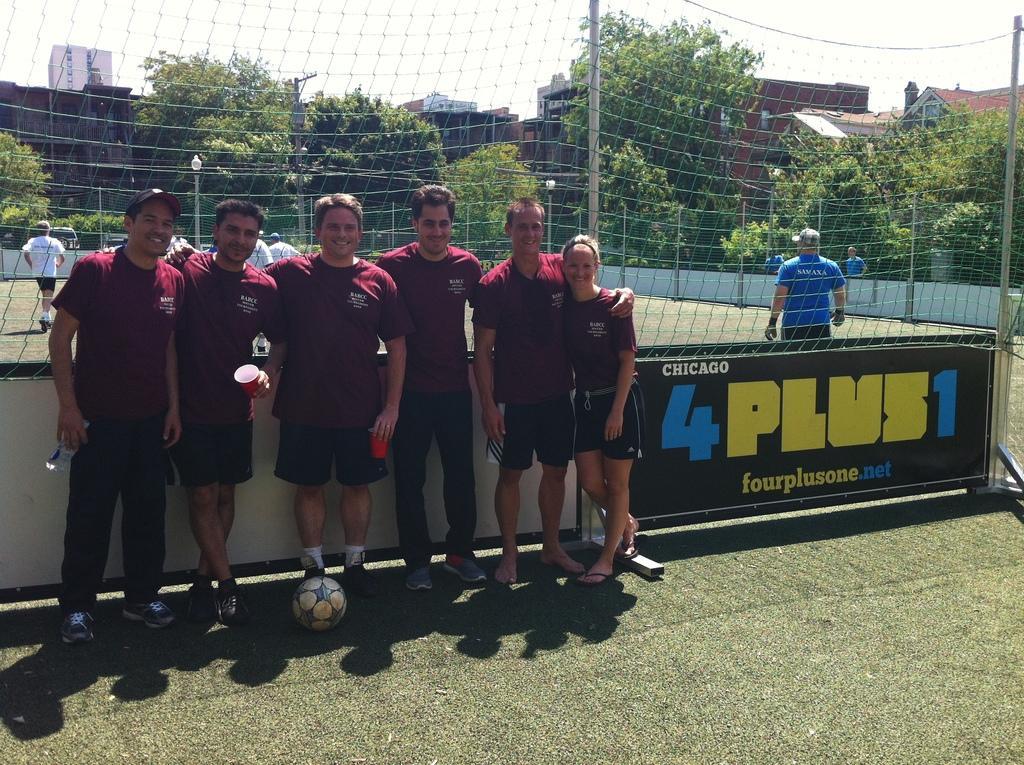Please provide a concise description of this image. In this image we can see the players standing on the ground. We can also see a ball, net, light poles, electrical pole, buildings and also the trees. We can also see the sky. 